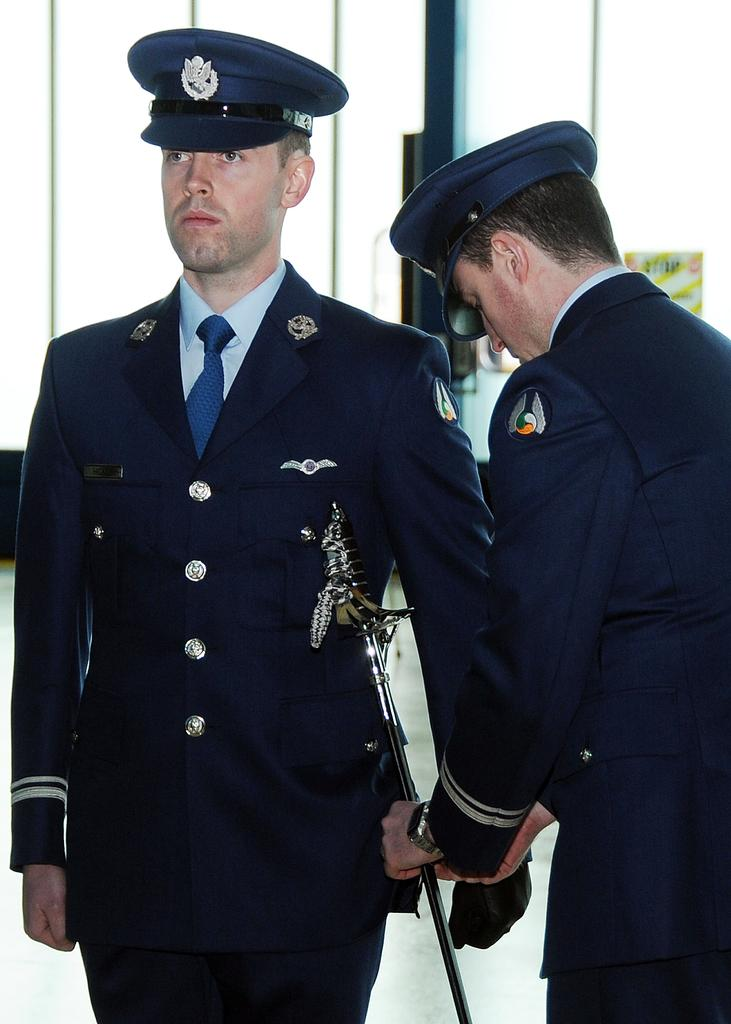How many people are in the image? There are two persons in the image. What is one person doing to the other person in the image? One person is injecting something into the other person. What hobbies do the persons in the image share? There is no information about the hobbies of the persons in the image. 